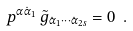Convert formula to latex. <formula><loc_0><loc_0><loc_500><loc_500>p ^ { \alpha \dot { \alpha } _ { 1 } } \, \tilde { g } _ { \dot { \alpha } _ { 1 } \cdots \dot { \alpha } _ { 2 s } } = 0 \ .</formula> 